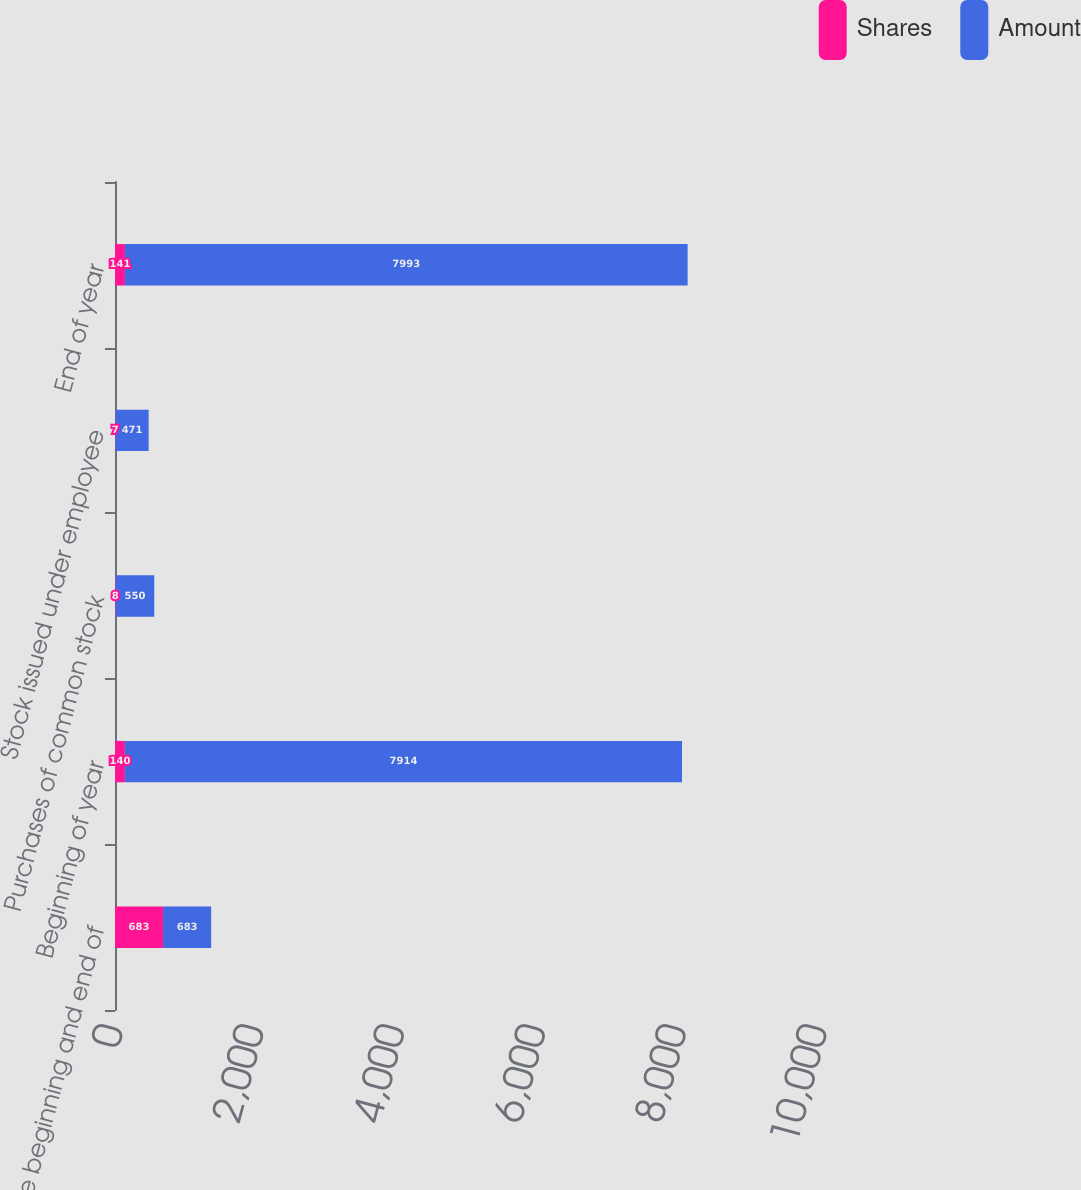Convert chart. <chart><loc_0><loc_0><loc_500><loc_500><stacked_bar_chart><ecel><fcel>Balance beginning and end of<fcel>Beginning of year<fcel>Purchases of common stock<fcel>Stock issued under employee<fcel>End of year<nl><fcel>Shares<fcel>683<fcel>140<fcel>8<fcel>7<fcel>141<nl><fcel>Amount<fcel>683<fcel>7914<fcel>550<fcel>471<fcel>7993<nl></chart> 